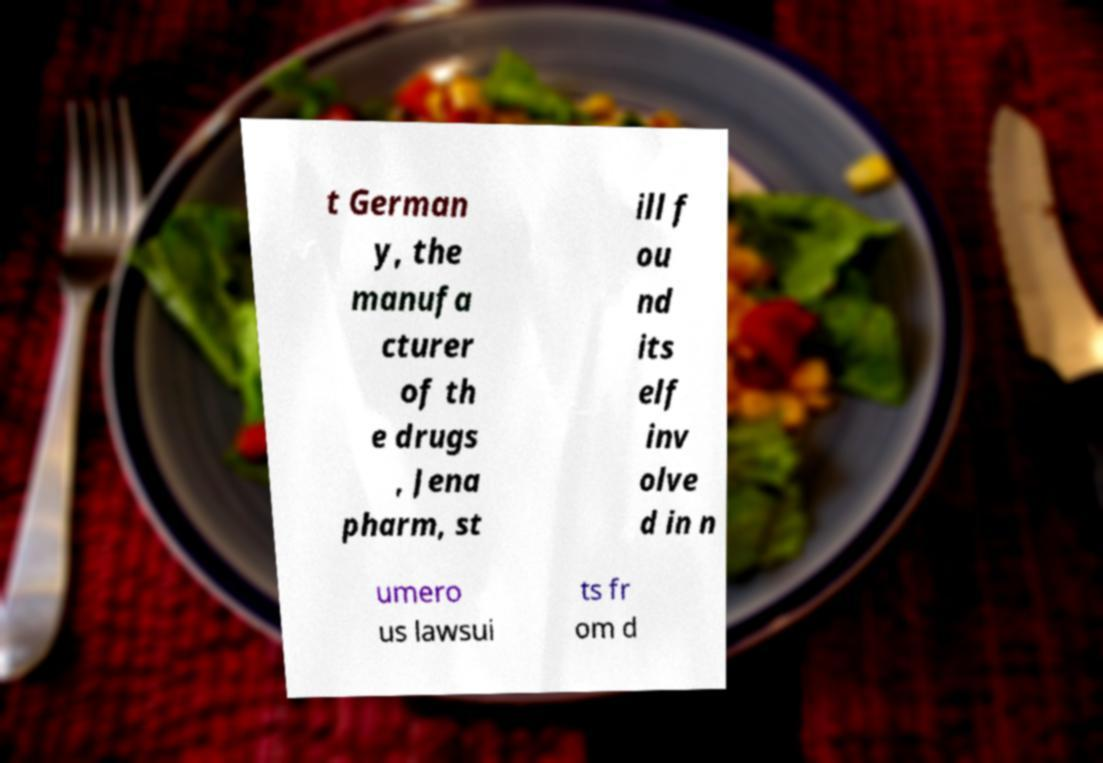What messages or text are displayed in this image? I need them in a readable, typed format. t German y, the manufa cturer of th e drugs , Jena pharm, st ill f ou nd its elf inv olve d in n umero us lawsui ts fr om d 